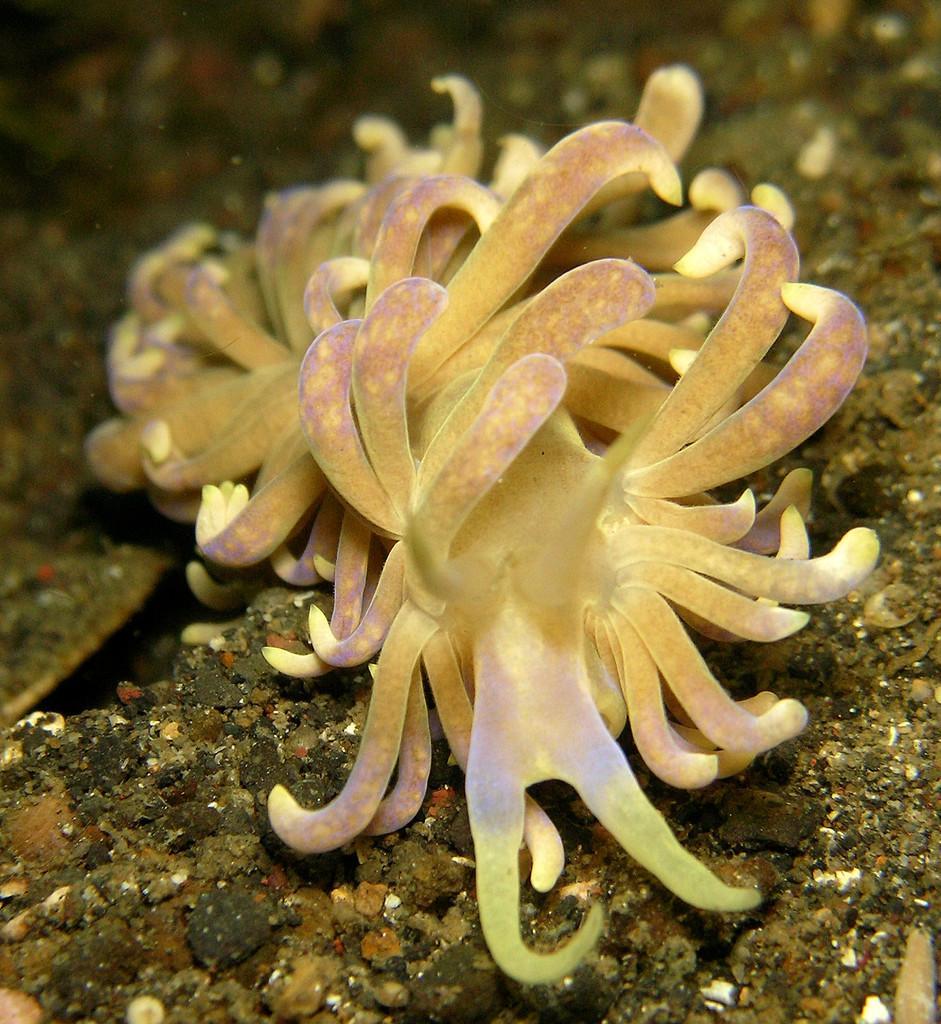Can you describe this image briefly? This is an image clicked inside the water. Here I can see few marine species. 